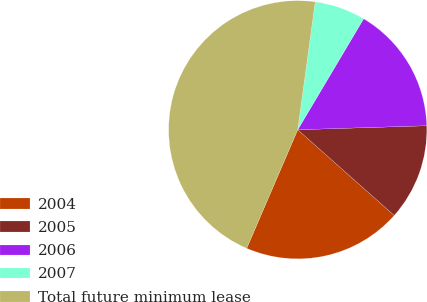Convert chart. <chart><loc_0><loc_0><loc_500><loc_500><pie_chart><fcel>2004<fcel>2005<fcel>2006<fcel>2007<fcel>Total future minimum lease<nl><fcel>19.91%<fcel>12.05%<fcel>15.98%<fcel>6.37%<fcel>45.7%<nl></chart> 